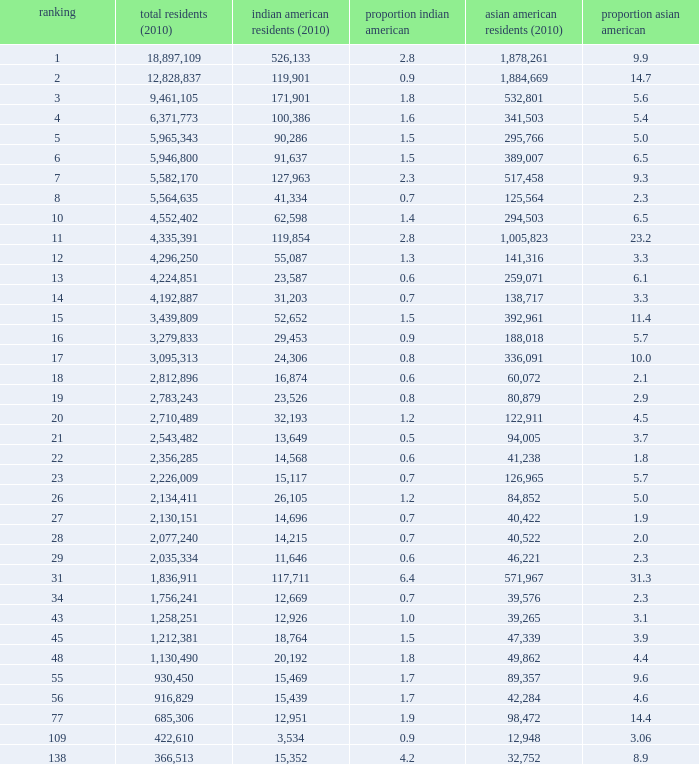What's the total population when the Asian American population is less than 60,072, the Indian American population is more than 14,696 and is 4.2% Indian American? 366513.0. 